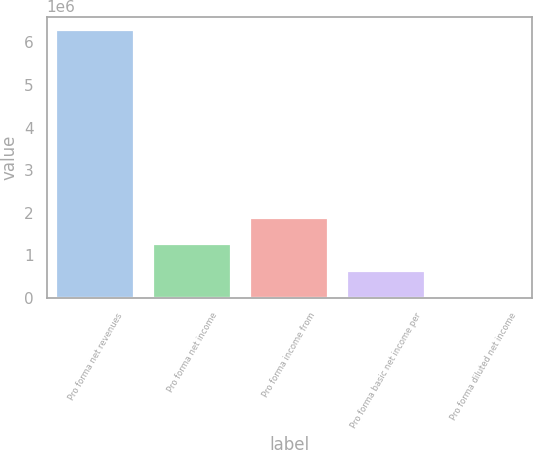Convert chart to OTSL. <chart><loc_0><loc_0><loc_500><loc_500><bar_chart><fcel>Pro forma net revenues<fcel>Pro forma net income<fcel>Pro forma income from<fcel>Pro forma basic net income per<fcel>Pro forma diluted net income<nl><fcel>6.28822e+06<fcel>1.25765e+06<fcel>1.88647e+06<fcel>628825<fcel>4.19<nl></chart> 